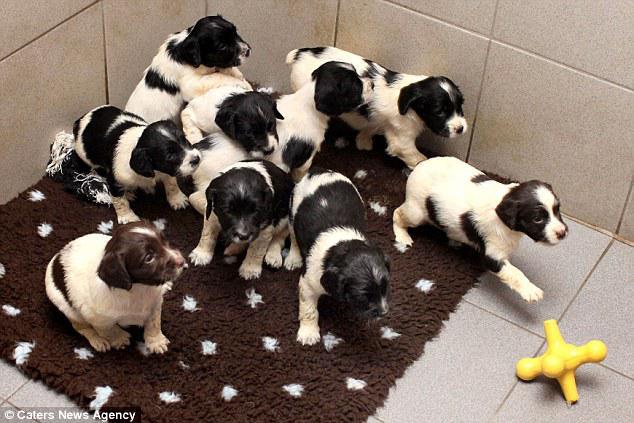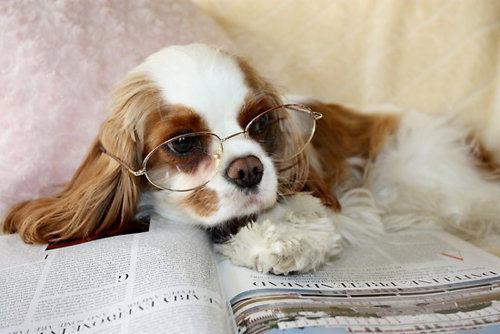The first image is the image on the left, the second image is the image on the right. Assess this claim about the two images: "An image shows a yellow toy next to at least one dog.". Correct or not? Answer yes or no. Yes. The first image is the image on the left, the second image is the image on the right. For the images shown, is this caption "There are more dogs in the image on the right than the image on the left." true? Answer yes or no. No. 